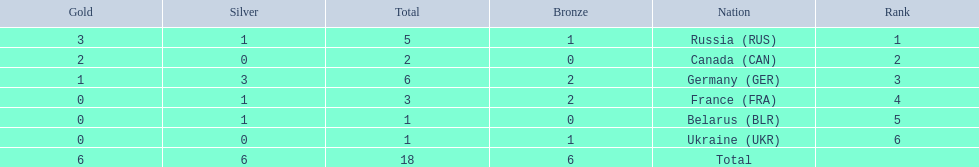What were all the countries that won biathlon medals? Russia (RUS), Canada (CAN), Germany (GER), France (FRA), Belarus (BLR), Ukraine (UKR). What were their medal counts? 5, 2, 6, 3, 1, 1. Of these, which is the largest number of medals? 6. Which country won this number of medals? Germany (GER). 